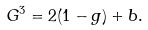Convert formula to latex. <formula><loc_0><loc_0><loc_500><loc_500>\ G ^ { 3 } = 2 ( 1 - g ) + b .</formula> 